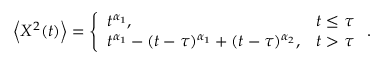Convert formula to latex. <formula><loc_0><loc_0><loc_500><loc_500>\begin{array} { r } { \left < X ^ { 2 } ( t ) \right > = \left \{ \begin{array} { l l } { t ^ { \alpha _ { 1 } } , } & { t \leq \tau } \\ { t ^ { \alpha _ { 1 } } - ( t - \tau ) ^ { \alpha _ { 1 } } + ( t - \tau ) ^ { \alpha _ { 2 } } , } & { t > \tau } \end{array} . } \end{array}</formula> 